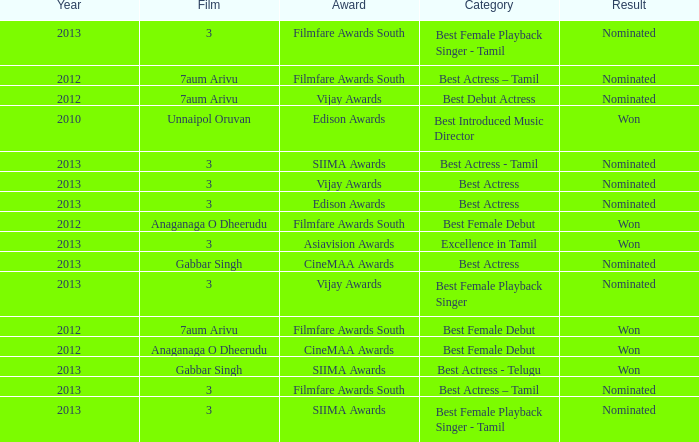What was the result associated with the cinemaa awards, and gabbar singh film? Nominated. 